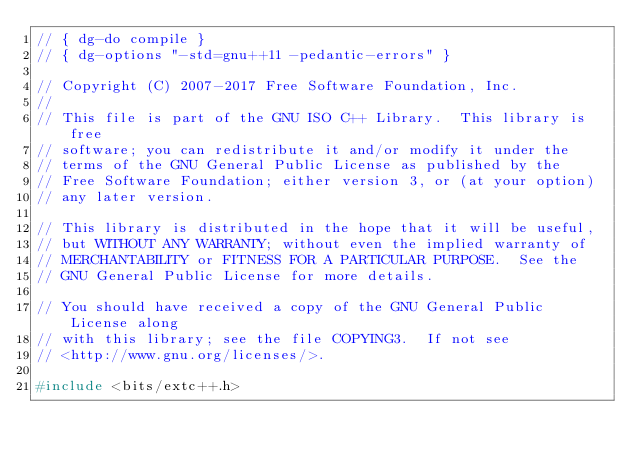Convert code to text. <code><loc_0><loc_0><loc_500><loc_500><_C++_>// { dg-do compile }
// { dg-options "-std=gnu++11 -pedantic-errors" }

// Copyright (C) 2007-2017 Free Software Foundation, Inc.
//
// This file is part of the GNU ISO C++ Library.  This library is free
// software; you can redistribute it and/or modify it under the
// terms of the GNU General Public License as published by the
// Free Software Foundation; either version 3, or (at your option)
// any later version.

// This library is distributed in the hope that it will be useful,
// but WITHOUT ANY WARRANTY; without even the implied warranty of
// MERCHANTABILITY or FITNESS FOR A PARTICULAR PURPOSE.  See the
// GNU General Public License for more details.

// You should have received a copy of the GNU General Public License along
// with this library; see the file COPYING3.  If not see
// <http://www.gnu.org/licenses/>.

#include <bits/extc++.h>
</code> 